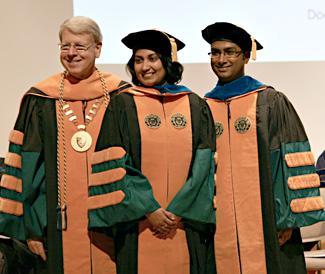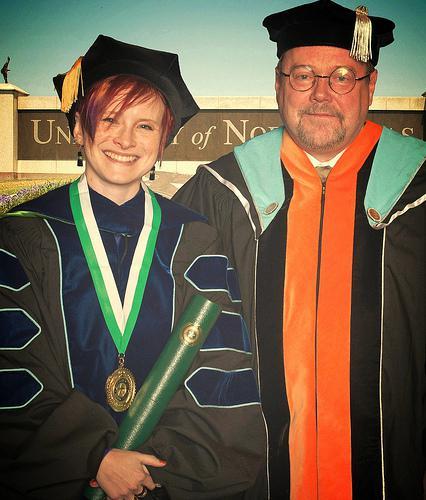The first image is the image on the left, the second image is the image on the right. For the images displayed, is the sentence "There are 2 people wearing graduation caps in the image on the right." factually correct? Answer yes or no. Yes. 